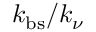Convert formula to latex. <formula><loc_0><loc_0><loc_500><loc_500>k _ { b s } / k _ { \nu }</formula> 